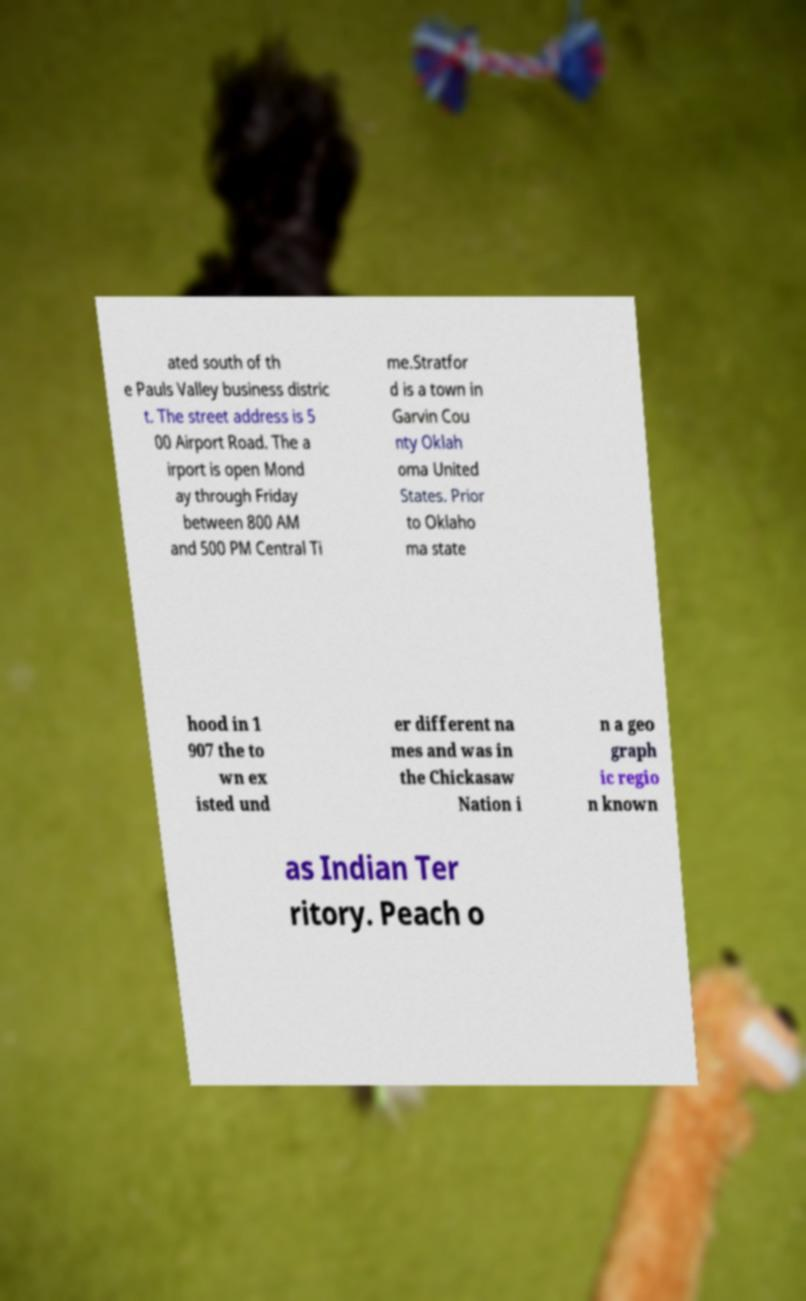Can you accurately transcribe the text from the provided image for me? ated south of th e Pauls Valley business distric t. The street address is 5 00 Airport Road. The a irport is open Mond ay through Friday between 800 AM and 500 PM Central Ti me.Stratfor d is a town in Garvin Cou nty Oklah oma United States. Prior to Oklaho ma state hood in 1 907 the to wn ex isted und er different na mes and was in the Chickasaw Nation i n a geo graph ic regio n known as Indian Ter ritory. Peach o 